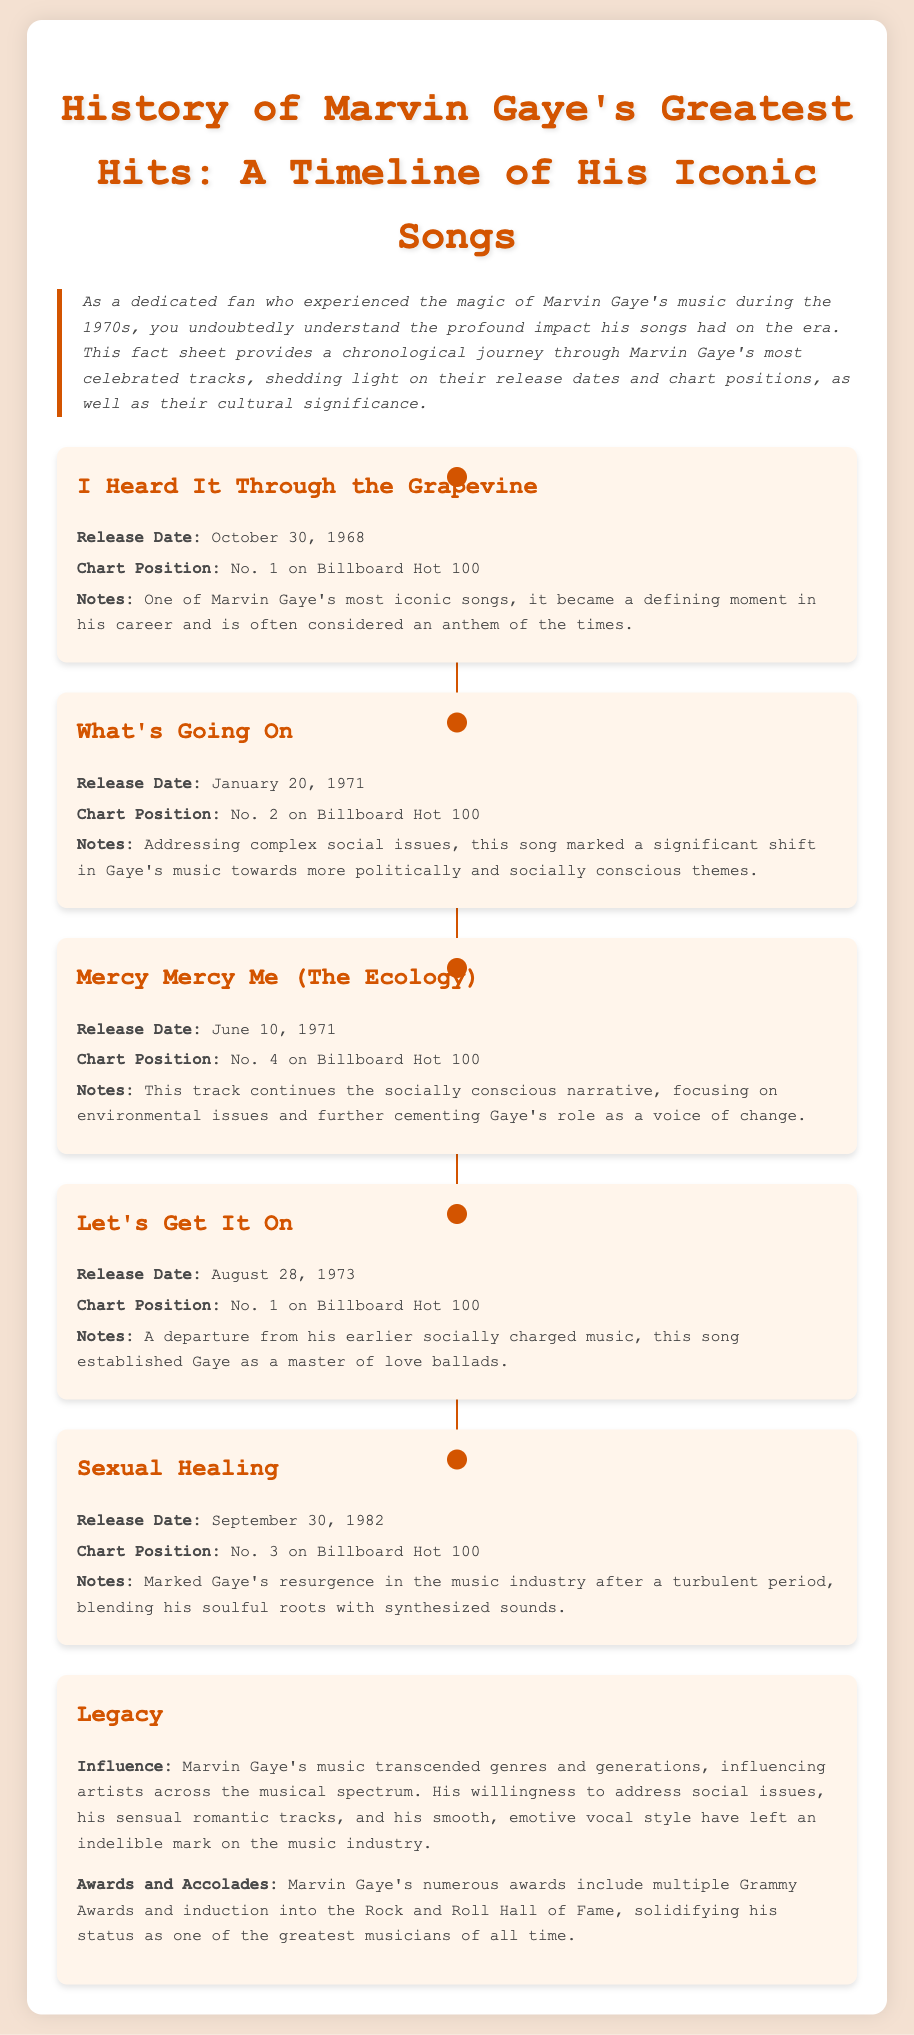What is the release date of "I Heard It Through the Grapevine"? The release date for "I Heard It Through the Grapevine" is specified in the document as October 30, 1968.
Answer: October 30, 1968 What is the chart position of "What's Going On"? The chart position of "What's Going On" on the Billboard Hot 100 is noted as No. 2 in the document.
Answer: No. 2 Which song was released on August 28, 1973? The document lists "Let's Get It On" as the song released on August 28, 1973.
Answer: Let's Get It On What theme does "Mercy Mercy Me (The Ecology)" focus on? The document mentions that "Mercy Mercy Me (The Ecology)" addresses environmental issues.
Answer: Environmental issues How many Grammy Awards has Marvin Gaye received? The document states that Marvin Gaye received multiple Grammy Awards, indicating he has won at least two.
Answer: Multiple What genre of music did "Sexual Healing" blend with synthesized sounds? The document highlights that "Sexual Healing" blended his soulful roots with synthesized sounds.
Answer: Soulful roots What does Marvin Gaye's music influence according to the document? The document suggests Marvin Gaye's music influenced artists across the musical spectrum.
Answer: Artists across the musical spectrum What year marks the release of "Mercy Mercy Me (The Ecology)"? The year mentioned for the release of "Mercy Mercy Me (The Ecology)" in the document is 1971.
Answer: 1971 